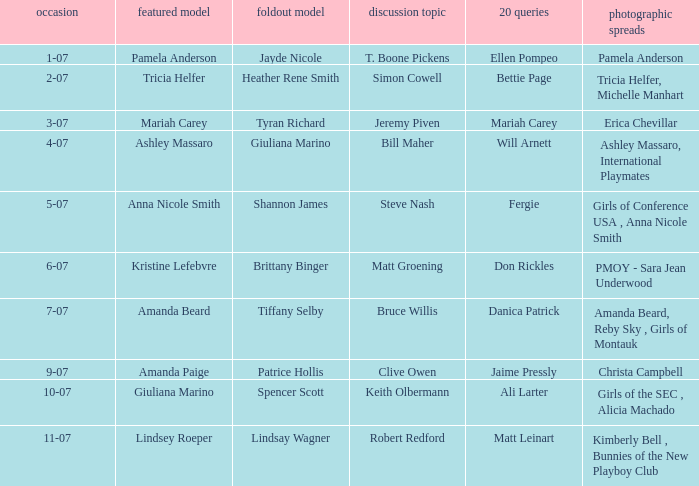Who was the centerfold model when the edition's pictorial featured amanda beard, reby sky, and girls of montauk? Tiffany Selby. 